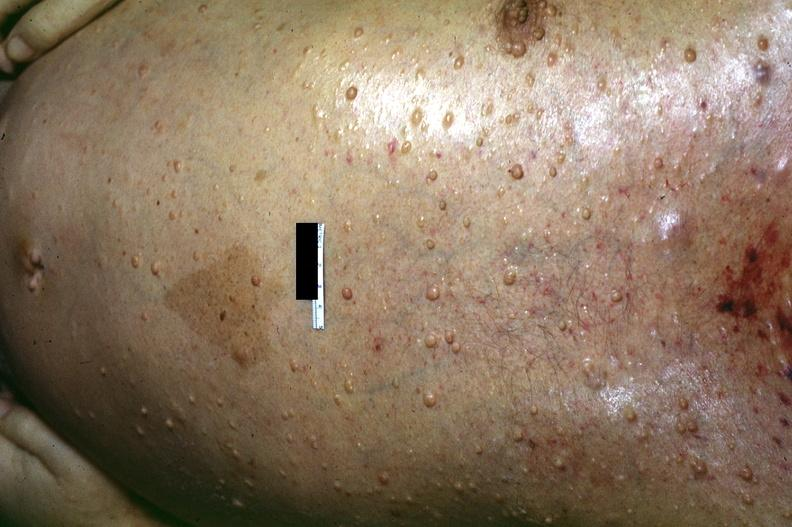where is this?
Answer the question using a single word or phrase. Skin 